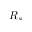<formula> <loc_0><loc_0><loc_500><loc_500>R _ { s }</formula> 